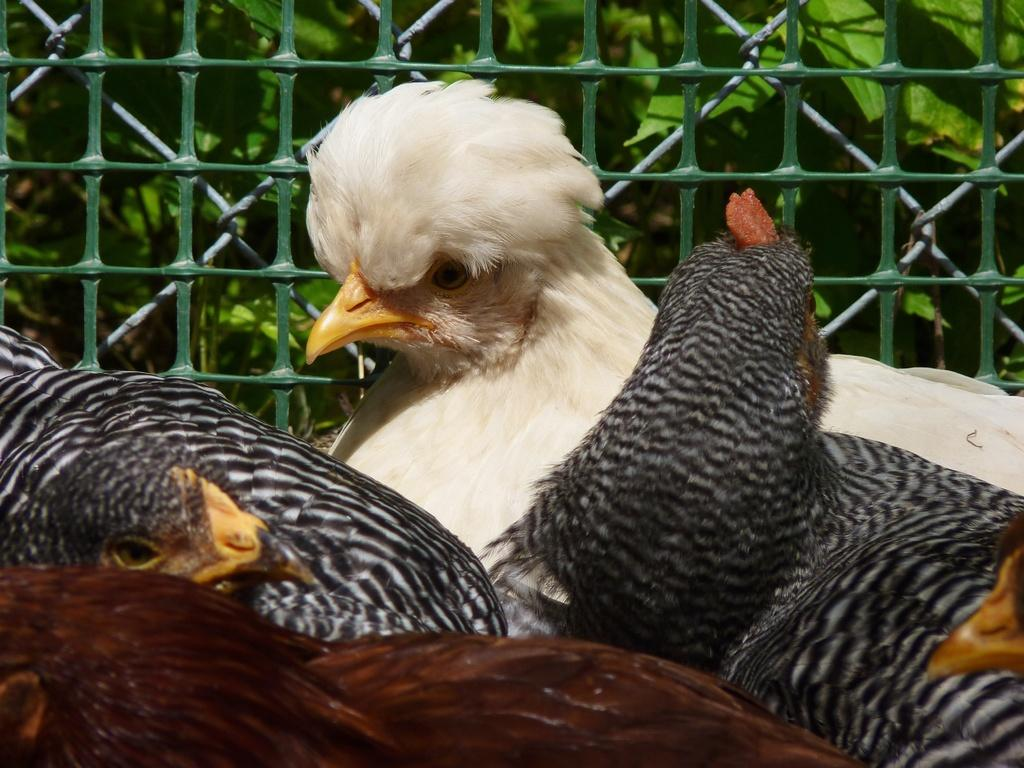What animals are in the foreground of the image? There are four hens in the foreground of the image. What can be seen in the background of the image? There is green mesh and greenery visible in the background of the image. What type of river can be seen flowing along the edge of the image? There is no river present in the image; it only features hens in the foreground and green mesh and greenery in the background. 